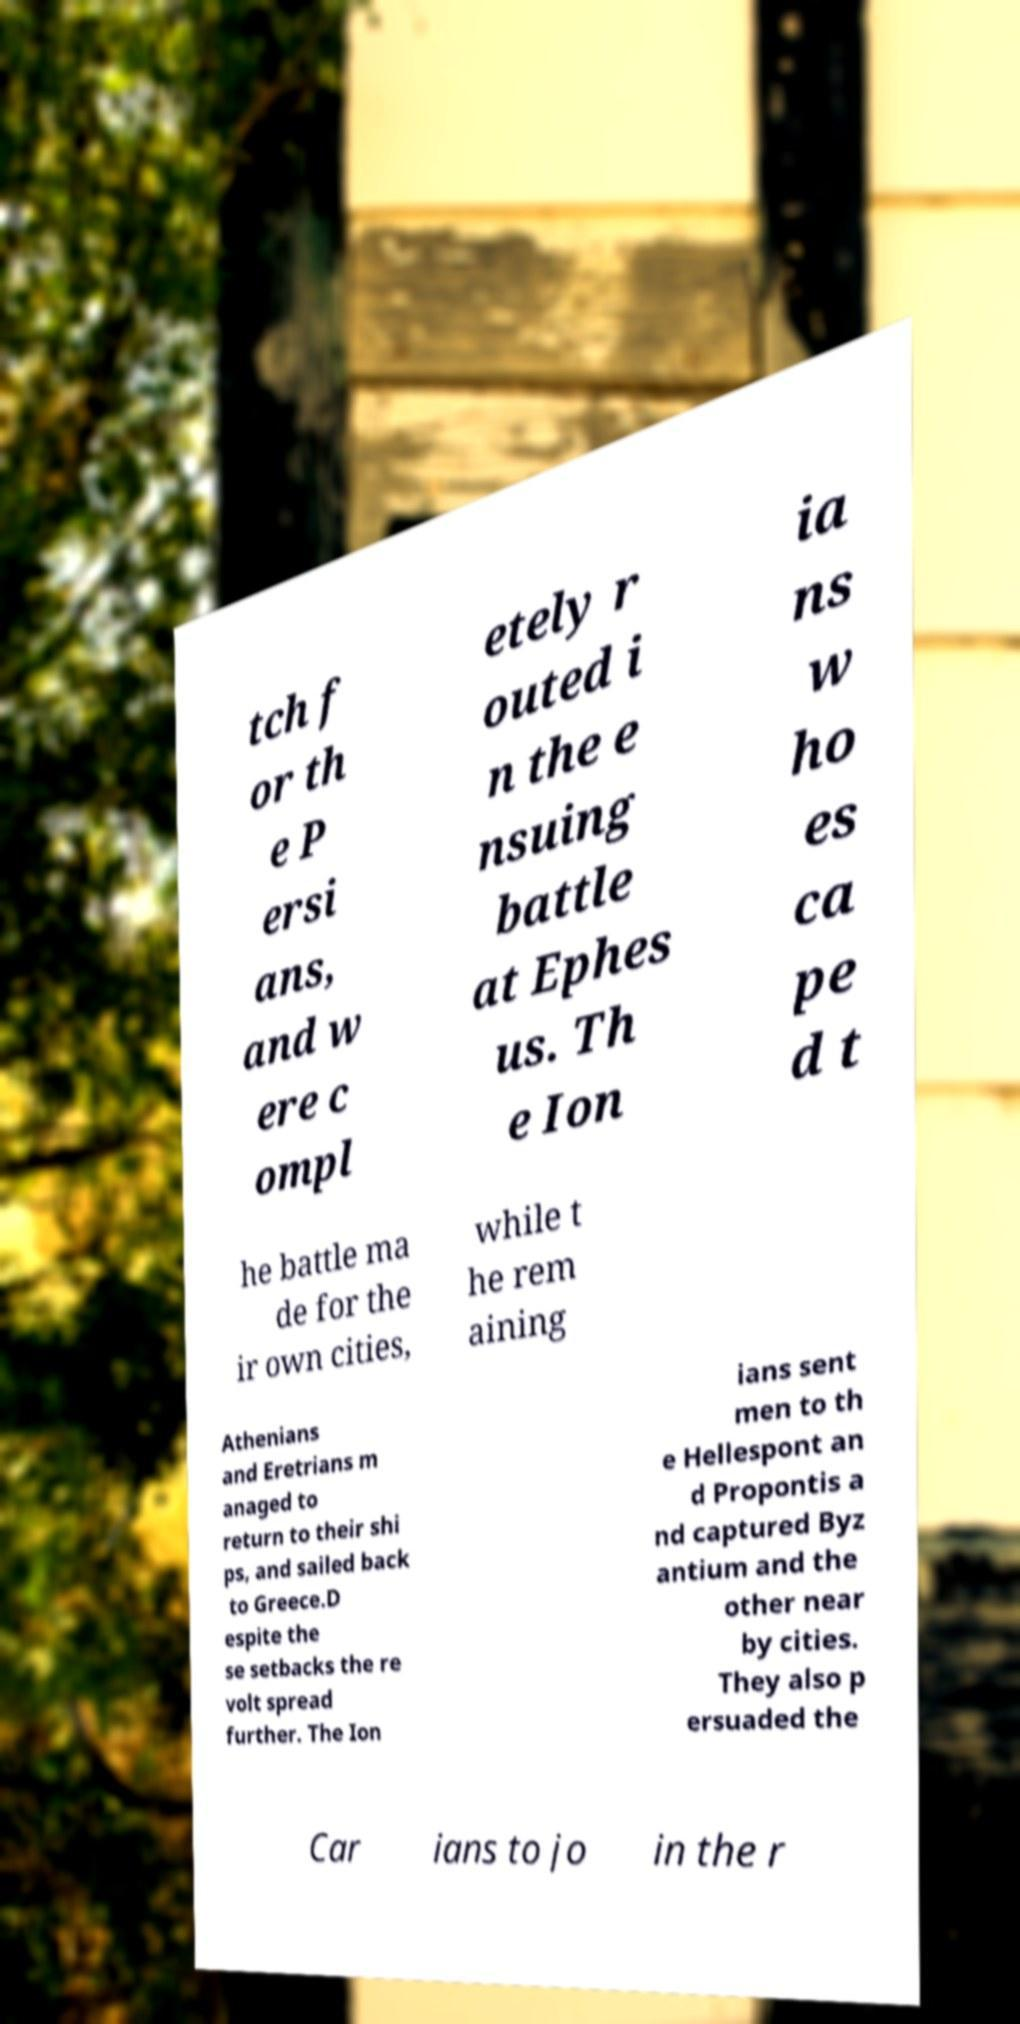What messages or text are displayed in this image? I need them in a readable, typed format. tch f or th e P ersi ans, and w ere c ompl etely r outed i n the e nsuing battle at Ephes us. Th e Ion ia ns w ho es ca pe d t he battle ma de for the ir own cities, while t he rem aining Athenians and Eretrians m anaged to return to their shi ps, and sailed back to Greece.D espite the se setbacks the re volt spread further. The Ion ians sent men to th e Hellespont an d Propontis a nd captured Byz antium and the other near by cities. They also p ersuaded the Car ians to jo in the r 